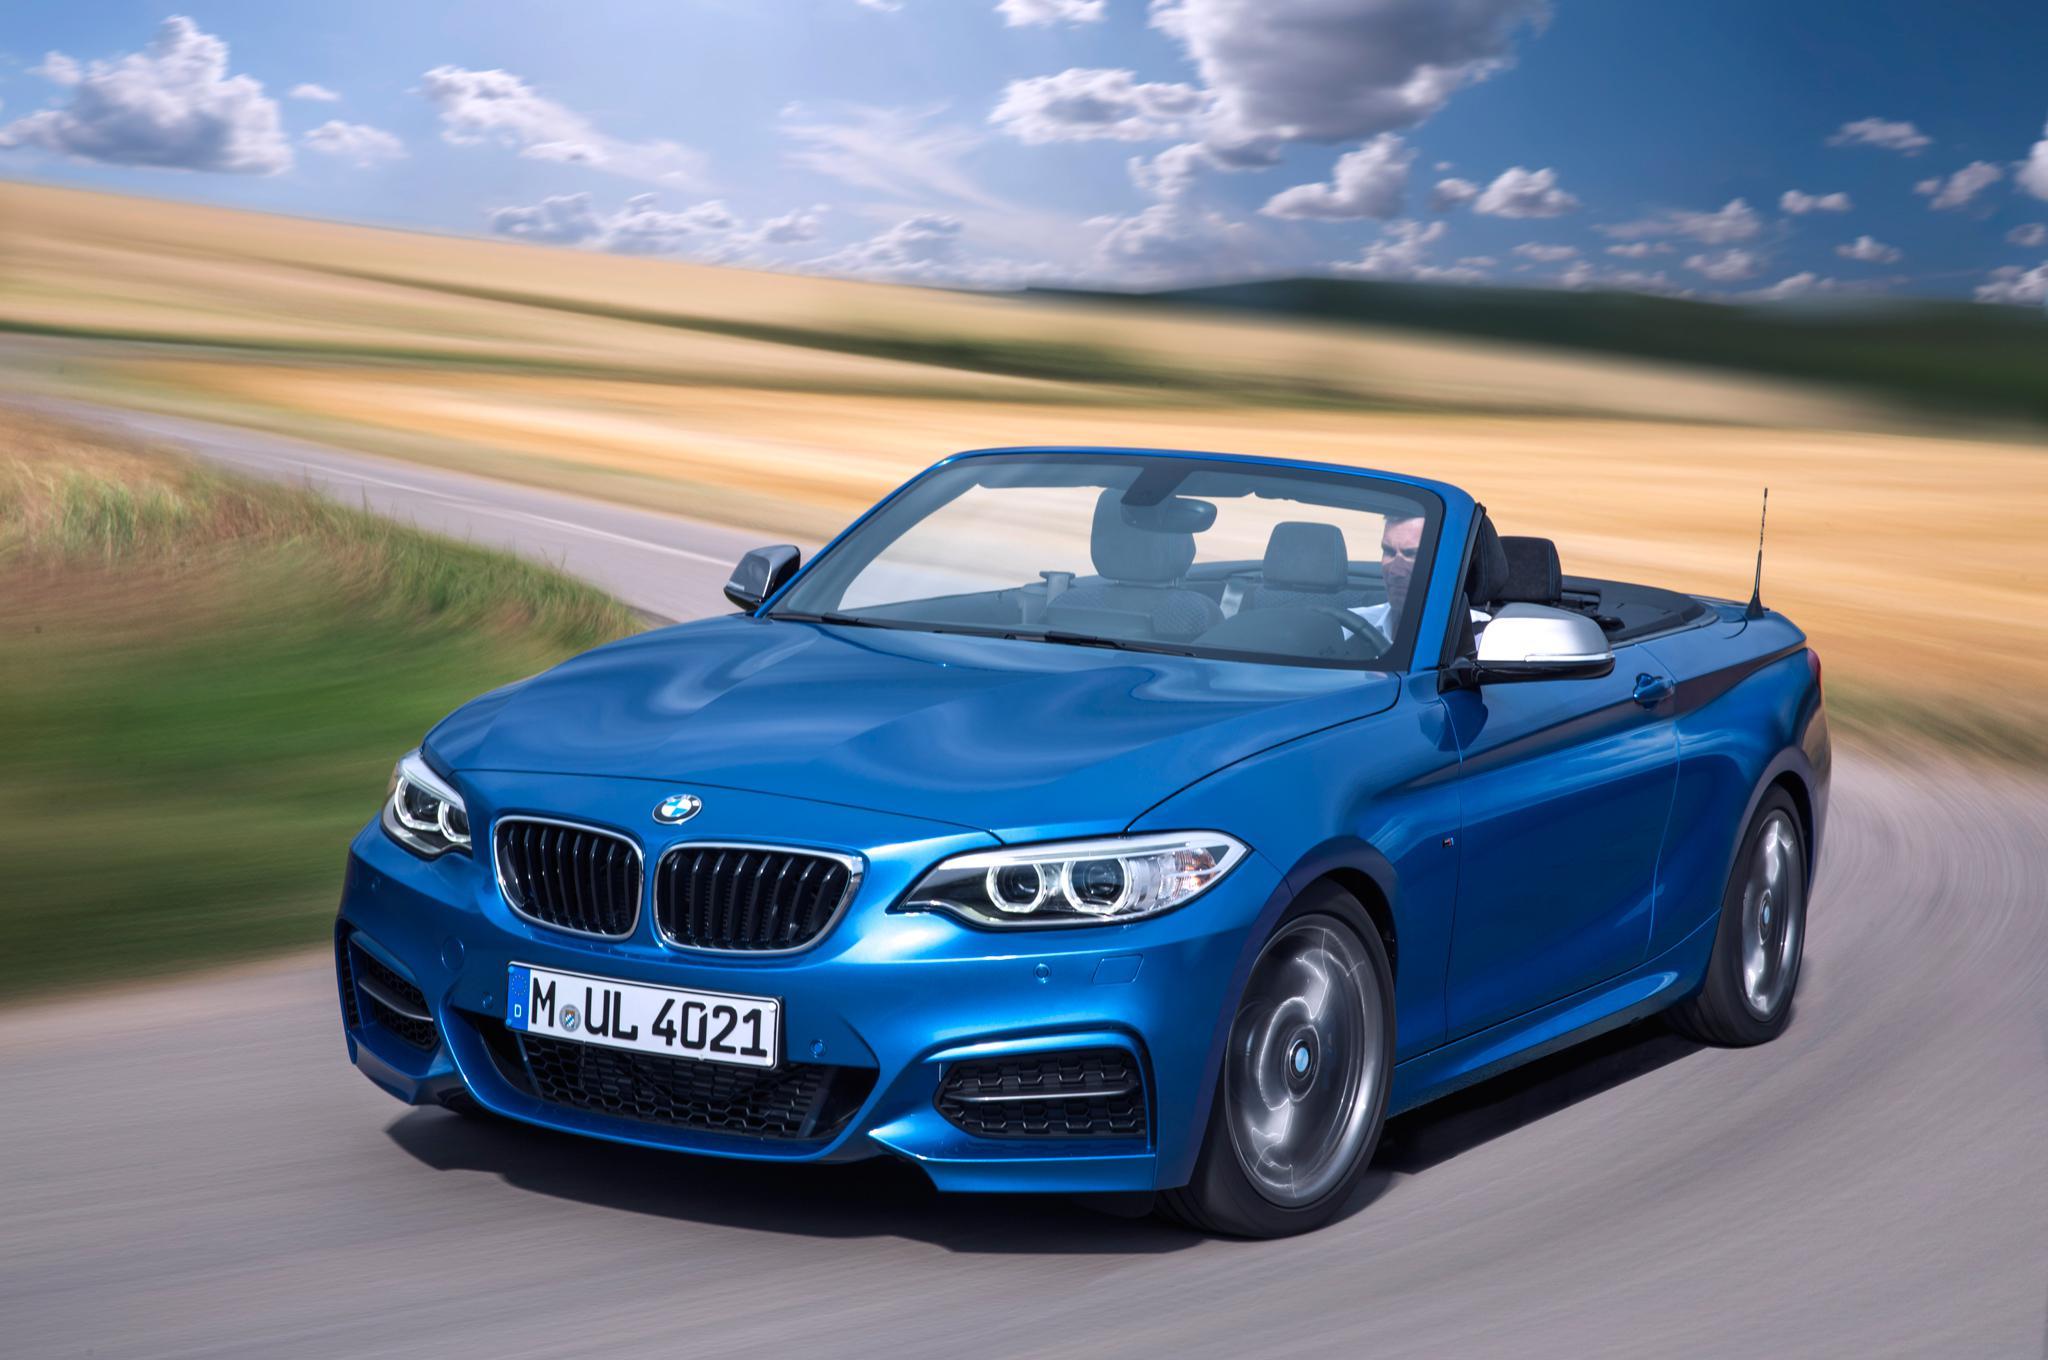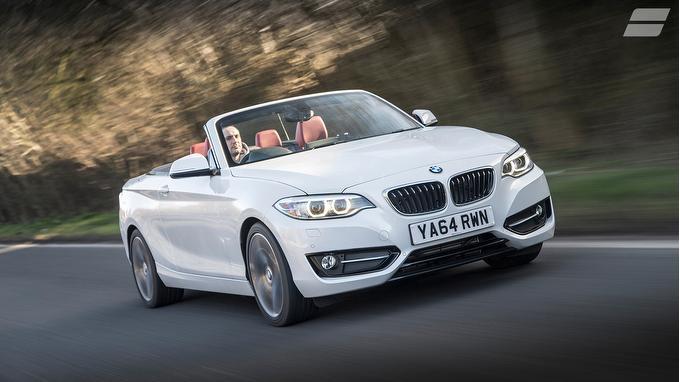The first image is the image on the left, the second image is the image on the right. For the images displayed, is the sentence "One of ther cars is blue." factually correct? Answer yes or no. Yes. The first image is the image on the left, the second image is the image on the right. Evaluate the accuracy of this statement regarding the images: "Left image shows a white convertible driving down a paved road.". Is it true? Answer yes or no. No. 